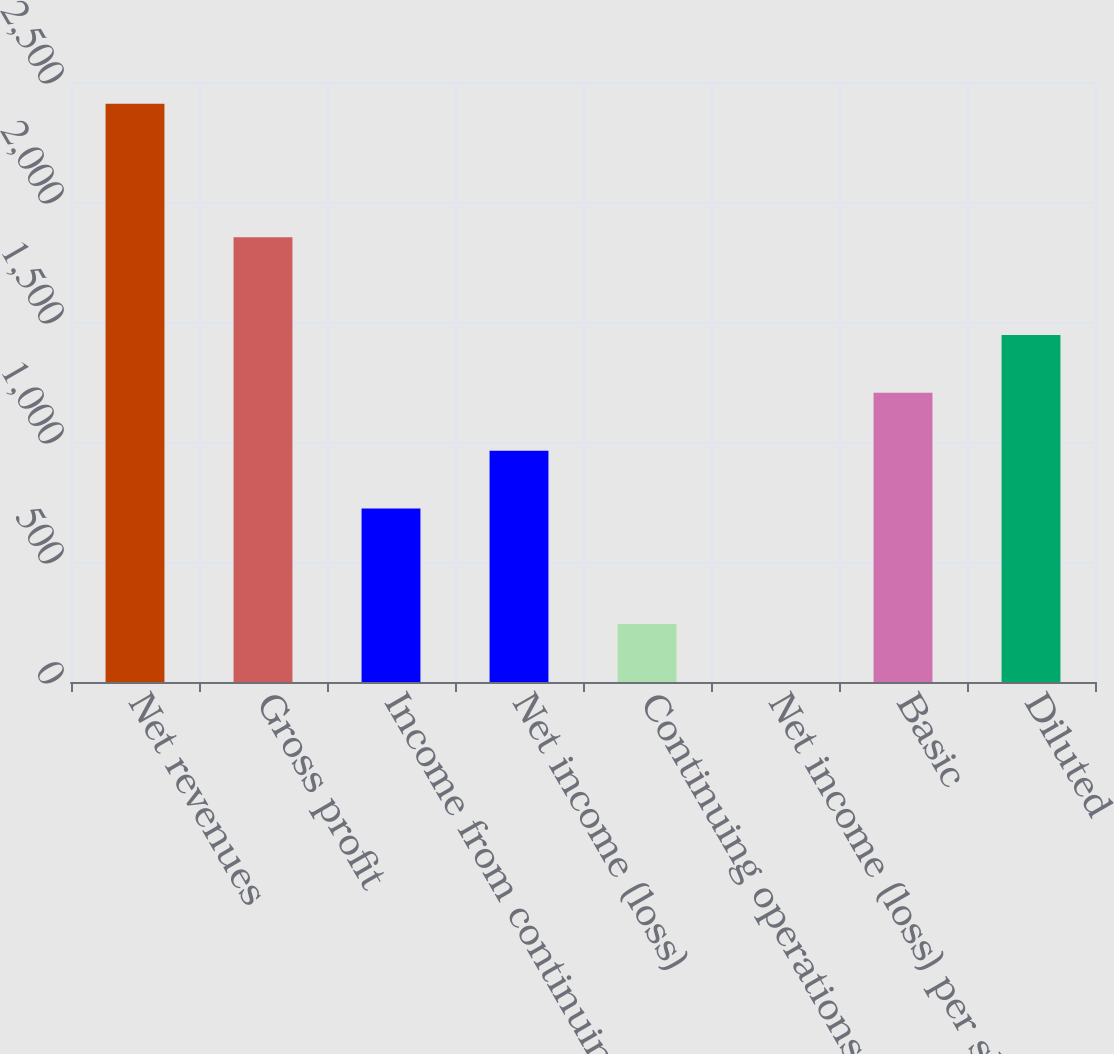Convert chart. <chart><loc_0><loc_0><loc_500><loc_500><bar_chart><fcel>Net revenues<fcel>Gross profit<fcel>Income from continuing<fcel>Net income (loss)<fcel>Continuing operations<fcel>Net income (loss) per share -<fcel>Basic<fcel>Diluted<nl><fcel>2409<fcel>1853<fcel>723.03<fcel>963.88<fcel>241.33<fcel>0.48<fcel>1204.73<fcel>1445.58<nl></chart> 